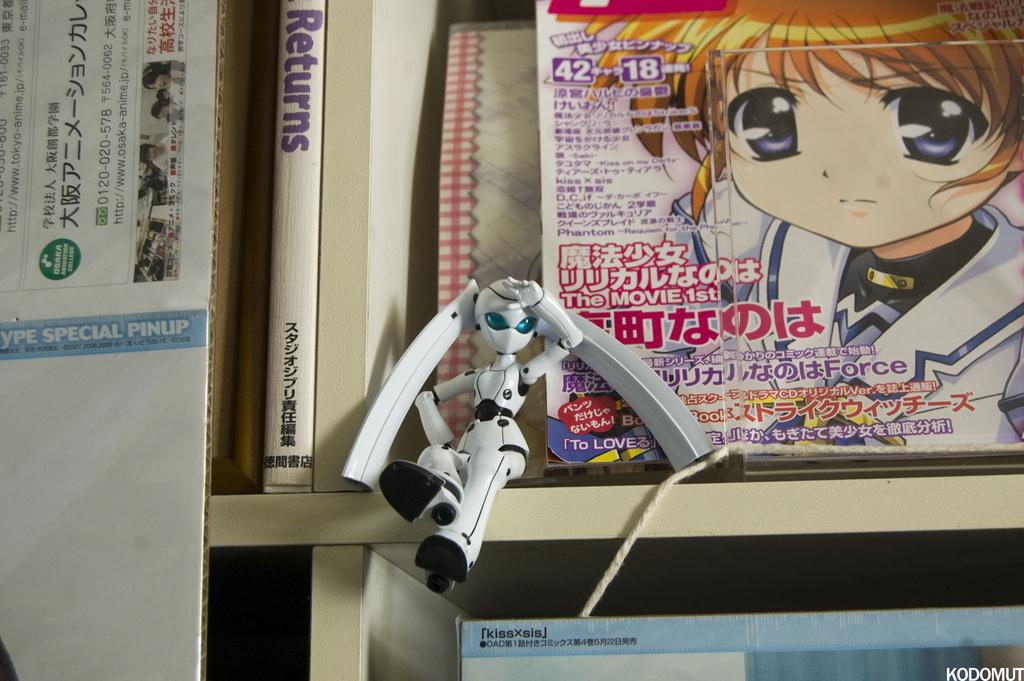<image>
Write a terse but informative summary of the picture. a book shelf with a book on the left with the word Returns on it 